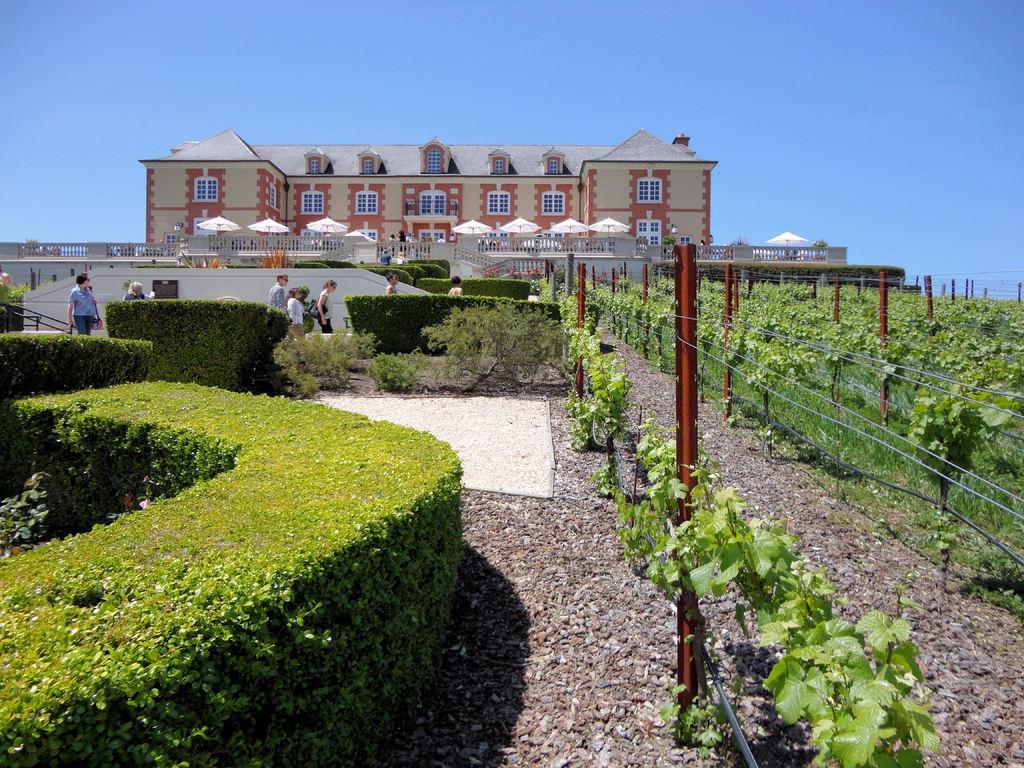Can you describe this image briefly? In this image we can see plants, human, fencing and field. Background of the image building is there. Top of the image sky is present. 